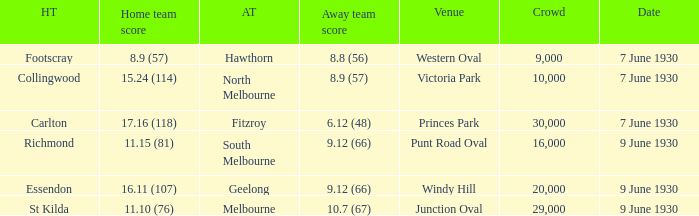What is the away team that scored 9.12 (66) at Windy Hill? Geelong. 